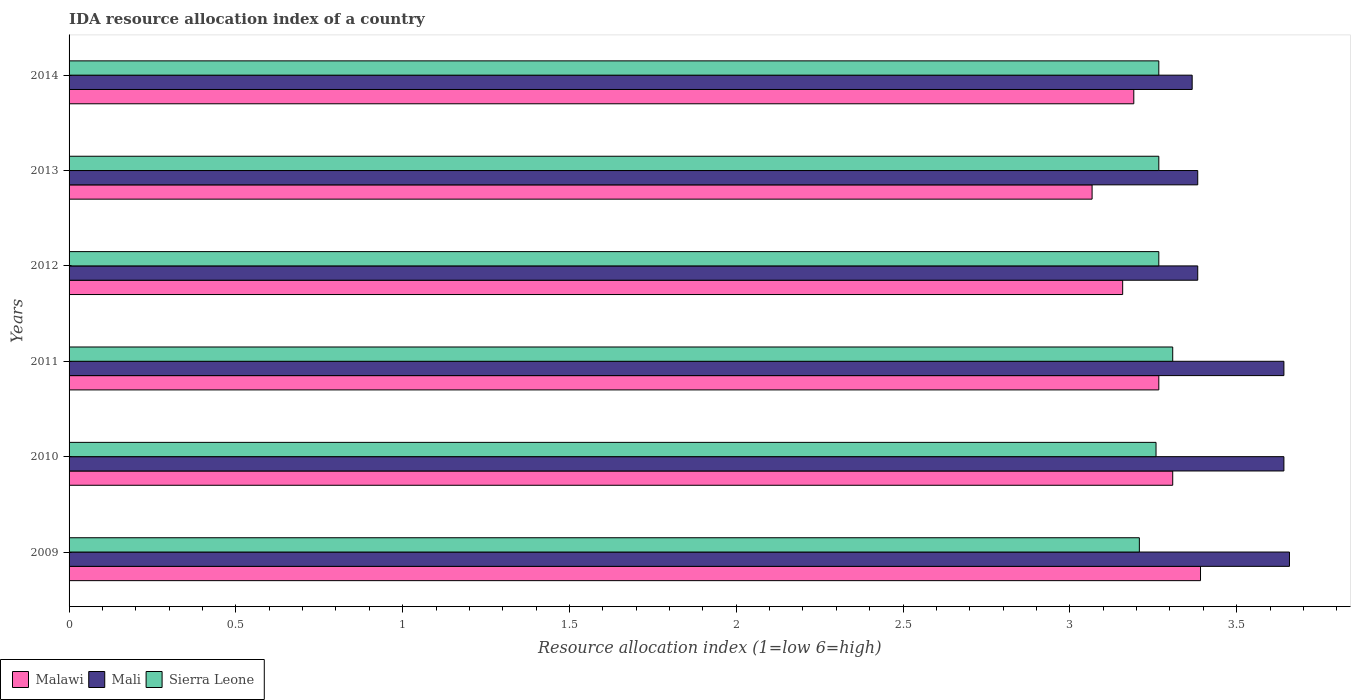How many groups of bars are there?
Provide a short and direct response. 6. Are the number of bars per tick equal to the number of legend labels?
Your response must be concise. Yes. How many bars are there on the 5th tick from the top?
Offer a very short reply. 3. What is the label of the 6th group of bars from the top?
Your response must be concise. 2009. In how many cases, is the number of bars for a given year not equal to the number of legend labels?
Offer a terse response. 0. What is the IDA resource allocation index in Sierra Leone in 2009?
Offer a very short reply. 3.21. Across all years, what is the maximum IDA resource allocation index in Mali?
Offer a terse response. 3.66. Across all years, what is the minimum IDA resource allocation index in Malawi?
Provide a succinct answer. 3.07. In which year was the IDA resource allocation index in Mali maximum?
Your response must be concise. 2009. In which year was the IDA resource allocation index in Sierra Leone minimum?
Your answer should be compact. 2009. What is the total IDA resource allocation index in Mali in the graph?
Ensure brevity in your answer.  21.07. What is the difference between the IDA resource allocation index in Mali in 2009 and that in 2010?
Provide a short and direct response. 0.02. What is the difference between the IDA resource allocation index in Sierra Leone in 2010 and the IDA resource allocation index in Mali in 2009?
Offer a terse response. -0.4. What is the average IDA resource allocation index in Malawi per year?
Give a very brief answer. 3.23. In the year 2010, what is the difference between the IDA resource allocation index in Malawi and IDA resource allocation index in Mali?
Make the answer very short. -0.33. What is the ratio of the IDA resource allocation index in Sierra Leone in 2009 to that in 2013?
Give a very brief answer. 0.98. What is the difference between the highest and the second highest IDA resource allocation index in Sierra Leone?
Make the answer very short. 0.04. What is the difference between the highest and the lowest IDA resource allocation index in Mali?
Keep it short and to the point. 0.29. Is the sum of the IDA resource allocation index in Sierra Leone in 2009 and 2010 greater than the maximum IDA resource allocation index in Malawi across all years?
Offer a very short reply. Yes. What does the 1st bar from the top in 2011 represents?
Provide a short and direct response. Sierra Leone. What does the 2nd bar from the bottom in 2014 represents?
Your answer should be very brief. Mali. Is it the case that in every year, the sum of the IDA resource allocation index in Malawi and IDA resource allocation index in Sierra Leone is greater than the IDA resource allocation index in Mali?
Your response must be concise. Yes. How many bars are there?
Keep it short and to the point. 18. How many years are there in the graph?
Keep it short and to the point. 6. What is the difference between two consecutive major ticks on the X-axis?
Provide a short and direct response. 0.5. Are the values on the major ticks of X-axis written in scientific E-notation?
Offer a terse response. No. Does the graph contain any zero values?
Make the answer very short. No. What is the title of the graph?
Give a very brief answer. IDA resource allocation index of a country. Does "Middle income" appear as one of the legend labels in the graph?
Your response must be concise. No. What is the label or title of the X-axis?
Offer a terse response. Resource allocation index (1=low 6=high). What is the label or title of the Y-axis?
Offer a terse response. Years. What is the Resource allocation index (1=low 6=high) in Malawi in 2009?
Give a very brief answer. 3.39. What is the Resource allocation index (1=low 6=high) of Mali in 2009?
Your answer should be very brief. 3.66. What is the Resource allocation index (1=low 6=high) of Sierra Leone in 2009?
Offer a very short reply. 3.21. What is the Resource allocation index (1=low 6=high) in Malawi in 2010?
Offer a terse response. 3.31. What is the Resource allocation index (1=low 6=high) in Mali in 2010?
Give a very brief answer. 3.64. What is the Resource allocation index (1=low 6=high) in Sierra Leone in 2010?
Your answer should be very brief. 3.26. What is the Resource allocation index (1=low 6=high) of Malawi in 2011?
Give a very brief answer. 3.27. What is the Resource allocation index (1=low 6=high) in Mali in 2011?
Give a very brief answer. 3.64. What is the Resource allocation index (1=low 6=high) in Sierra Leone in 2011?
Offer a very short reply. 3.31. What is the Resource allocation index (1=low 6=high) of Malawi in 2012?
Make the answer very short. 3.16. What is the Resource allocation index (1=low 6=high) of Mali in 2012?
Your answer should be compact. 3.38. What is the Resource allocation index (1=low 6=high) of Sierra Leone in 2012?
Your answer should be very brief. 3.27. What is the Resource allocation index (1=low 6=high) in Malawi in 2013?
Offer a very short reply. 3.07. What is the Resource allocation index (1=low 6=high) in Mali in 2013?
Your response must be concise. 3.38. What is the Resource allocation index (1=low 6=high) of Sierra Leone in 2013?
Make the answer very short. 3.27. What is the Resource allocation index (1=low 6=high) of Malawi in 2014?
Your response must be concise. 3.19. What is the Resource allocation index (1=low 6=high) in Mali in 2014?
Keep it short and to the point. 3.37. What is the Resource allocation index (1=low 6=high) in Sierra Leone in 2014?
Keep it short and to the point. 3.27. Across all years, what is the maximum Resource allocation index (1=low 6=high) in Malawi?
Provide a short and direct response. 3.39. Across all years, what is the maximum Resource allocation index (1=low 6=high) of Mali?
Offer a terse response. 3.66. Across all years, what is the maximum Resource allocation index (1=low 6=high) in Sierra Leone?
Your answer should be very brief. 3.31. Across all years, what is the minimum Resource allocation index (1=low 6=high) in Malawi?
Offer a very short reply. 3.07. Across all years, what is the minimum Resource allocation index (1=low 6=high) in Mali?
Offer a very short reply. 3.37. Across all years, what is the minimum Resource allocation index (1=low 6=high) of Sierra Leone?
Your answer should be very brief. 3.21. What is the total Resource allocation index (1=low 6=high) in Malawi in the graph?
Offer a terse response. 19.38. What is the total Resource allocation index (1=low 6=high) of Mali in the graph?
Your answer should be compact. 21.07. What is the total Resource allocation index (1=low 6=high) of Sierra Leone in the graph?
Ensure brevity in your answer.  19.57. What is the difference between the Resource allocation index (1=low 6=high) in Malawi in 2009 and that in 2010?
Provide a short and direct response. 0.08. What is the difference between the Resource allocation index (1=low 6=high) in Mali in 2009 and that in 2010?
Make the answer very short. 0.02. What is the difference between the Resource allocation index (1=low 6=high) in Sierra Leone in 2009 and that in 2010?
Offer a terse response. -0.05. What is the difference between the Resource allocation index (1=low 6=high) of Malawi in 2009 and that in 2011?
Provide a succinct answer. 0.12. What is the difference between the Resource allocation index (1=low 6=high) in Mali in 2009 and that in 2011?
Provide a succinct answer. 0.02. What is the difference between the Resource allocation index (1=low 6=high) in Malawi in 2009 and that in 2012?
Your answer should be compact. 0.23. What is the difference between the Resource allocation index (1=low 6=high) of Mali in 2009 and that in 2012?
Offer a very short reply. 0.28. What is the difference between the Resource allocation index (1=low 6=high) in Sierra Leone in 2009 and that in 2012?
Your answer should be compact. -0.06. What is the difference between the Resource allocation index (1=low 6=high) in Malawi in 2009 and that in 2013?
Offer a terse response. 0.33. What is the difference between the Resource allocation index (1=low 6=high) of Mali in 2009 and that in 2013?
Keep it short and to the point. 0.28. What is the difference between the Resource allocation index (1=low 6=high) in Sierra Leone in 2009 and that in 2013?
Provide a succinct answer. -0.06. What is the difference between the Resource allocation index (1=low 6=high) in Mali in 2009 and that in 2014?
Your answer should be very brief. 0.29. What is the difference between the Resource allocation index (1=low 6=high) in Sierra Leone in 2009 and that in 2014?
Your answer should be very brief. -0.06. What is the difference between the Resource allocation index (1=low 6=high) in Malawi in 2010 and that in 2011?
Your answer should be compact. 0.04. What is the difference between the Resource allocation index (1=low 6=high) in Mali in 2010 and that in 2012?
Ensure brevity in your answer.  0.26. What is the difference between the Resource allocation index (1=low 6=high) in Sierra Leone in 2010 and that in 2012?
Provide a short and direct response. -0.01. What is the difference between the Resource allocation index (1=low 6=high) of Malawi in 2010 and that in 2013?
Offer a terse response. 0.24. What is the difference between the Resource allocation index (1=low 6=high) in Mali in 2010 and that in 2013?
Ensure brevity in your answer.  0.26. What is the difference between the Resource allocation index (1=low 6=high) in Sierra Leone in 2010 and that in 2013?
Your response must be concise. -0.01. What is the difference between the Resource allocation index (1=low 6=high) of Malawi in 2010 and that in 2014?
Keep it short and to the point. 0.12. What is the difference between the Resource allocation index (1=low 6=high) of Mali in 2010 and that in 2014?
Provide a succinct answer. 0.28. What is the difference between the Resource allocation index (1=low 6=high) of Sierra Leone in 2010 and that in 2014?
Your answer should be very brief. -0.01. What is the difference between the Resource allocation index (1=low 6=high) in Malawi in 2011 and that in 2012?
Offer a very short reply. 0.11. What is the difference between the Resource allocation index (1=low 6=high) in Mali in 2011 and that in 2012?
Offer a terse response. 0.26. What is the difference between the Resource allocation index (1=low 6=high) of Sierra Leone in 2011 and that in 2012?
Make the answer very short. 0.04. What is the difference between the Resource allocation index (1=low 6=high) in Mali in 2011 and that in 2013?
Your answer should be very brief. 0.26. What is the difference between the Resource allocation index (1=low 6=high) of Sierra Leone in 2011 and that in 2013?
Ensure brevity in your answer.  0.04. What is the difference between the Resource allocation index (1=low 6=high) in Malawi in 2011 and that in 2014?
Your answer should be compact. 0.07. What is the difference between the Resource allocation index (1=low 6=high) of Mali in 2011 and that in 2014?
Provide a short and direct response. 0.28. What is the difference between the Resource allocation index (1=low 6=high) in Sierra Leone in 2011 and that in 2014?
Your answer should be very brief. 0.04. What is the difference between the Resource allocation index (1=low 6=high) of Malawi in 2012 and that in 2013?
Make the answer very short. 0.09. What is the difference between the Resource allocation index (1=low 6=high) of Malawi in 2012 and that in 2014?
Your answer should be compact. -0.03. What is the difference between the Resource allocation index (1=low 6=high) in Mali in 2012 and that in 2014?
Your response must be concise. 0.02. What is the difference between the Resource allocation index (1=low 6=high) in Sierra Leone in 2012 and that in 2014?
Make the answer very short. -0. What is the difference between the Resource allocation index (1=low 6=high) in Malawi in 2013 and that in 2014?
Your response must be concise. -0.12. What is the difference between the Resource allocation index (1=low 6=high) in Mali in 2013 and that in 2014?
Keep it short and to the point. 0.02. What is the difference between the Resource allocation index (1=low 6=high) of Sierra Leone in 2013 and that in 2014?
Keep it short and to the point. -0. What is the difference between the Resource allocation index (1=low 6=high) in Malawi in 2009 and the Resource allocation index (1=low 6=high) in Sierra Leone in 2010?
Provide a short and direct response. 0.13. What is the difference between the Resource allocation index (1=low 6=high) of Mali in 2009 and the Resource allocation index (1=low 6=high) of Sierra Leone in 2010?
Your answer should be very brief. 0.4. What is the difference between the Resource allocation index (1=low 6=high) in Malawi in 2009 and the Resource allocation index (1=low 6=high) in Sierra Leone in 2011?
Your answer should be compact. 0.08. What is the difference between the Resource allocation index (1=low 6=high) in Mali in 2009 and the Resource allocation index (1=low 6=high) in Sierra Leone in 2011?
Offer a very short reply. 0.35. What is the difference between the Resource allocation index (1=low 6=high) of Malawi in 2009 and the Resource allocation index (1=low 6=high) of Mali in 2012?
Ensure brevity in your answer.  0.01. What is the difference between the Resource allocation index (1=low 6=high) in Malawi in 2009 and the Resource allocation index (1=low 6=high) in Sierra Leone in 2012?
Make the answer very short. 0.12. What is the difference between the Resource allocation index (1=low 6=high) of Mali in 2009 and the Resource allocation index (1=low 6=high) of Sierra Leone in 2012?
Provide a short and direct response. 0.39. What is the difference between the Resource allocation index (1=low 6=high) in Malawi in 2009 and the Resource allocation index (1=low 6=high) in Mali in 2013?
Make the answer very short. 0.01. What is the difference between the Resource allocation index (1=low 6=high) of Mali in 2009 and the Resource allocation index (1=low 6=high) of Sierra Leone in 2013?
Your response must be concise. 0.39. What is the difference between the Resource allocation index (1=low 6=high) of Malawi in 2009 and the Resource allocation index (1=low 6=high) of Mali in 2014?
Give a very brief answer. 0.03. What is the difference between the Resource allocation index (1=low 6=high) in Malawi in 2009 and the Resource allocation index (1=low 6=high) in Sierra Leone in 2014?
Ensure brevity in your answer.  0.12. What is the difference between the Resource allocation index (1=low 6=high) of Mali in 2009 and the Resource allocation index (1=low 6=high) of Sierra Leone in 2014?
Ensure brevity in your answer.  0.39. What is the difference between the Resource allocation index (1=low 6=high) in Malawi in 2010 and the Resource allocation index (1=low 6=high) in Sierra Leone in 2011?
Provide a short and direct response. 0. What is the difference between the Resource allocation index (1=low 6=high) in Malawi in 2010 and the Resource allocation index (1=low 6=high) in Mali in 2012?
Provide a short and direct response. -0.07. What is the difference between the Resource allocation index (1=low 6=high) of Malawi in 2010 and the Resource allocation index (1=low 6=high) of Sierra Leone in 2012?
Offer a terse response. 0.04. What is the difference between the Resource allocation index (1=low 6=high) in Malawi in 2010 and the Resource allocation index (1=low 6=high) in Mali in 2013?
Your answer should be very brief. -0.07. What is the difference between the Resource allocation index (1=low 6=high) in Malawi in 2010 and the Resource allocation index (1=low 6=high) in Sierra Leone in 2013?
Make the answer very short. 0.04. What is the difference between the Resource allocation index (1=low 6=high) of Malawi in 2010 and the Resource allocation index (1=low 6=high) of Mali in 2014?
Your answer should be compact. -0.06. What is the difference between the Resource allocation index (1=low 6=high) of Malawi in 2010 and the Resource allocation index (1=low 6=high) of Sierra Leone in 2014?
Your answer should be very brief. 0.04. What is the difference between the Resource allocation index (1=low 6=high) in Malawi in 2011 and the Resource allocation index (1=low 6=high) in Mali in 2012?
Your answer should be compact. -0.12. What is the difference between the Resource allocation index (1=low 6=high) of Malawi in 2011 and the Resource allocation index (1=low 6=high) of Mali in 2013?
Provide a short and direct response. -0.12. What is the difference between the Resource allocation index (1=low 6=high) in Malawi in 2012 and the Resource allocation index (1=low 6=high) in Mali in 2013?
Your response must be concise. -0.23. What is the difference between the Resource allocation index (1=low 6=high) in Malawi in 2012 and the Resource allocation index (1=low 6=high) in Sierra Leone in 2013?
Give a very brief answer. -0.11. What is the difference between the Resource allocation index (1=low 6=high) in Mali in 2012 and the Resource allocation index (1=low 6=high) in Sierra Leone in 2013?
Your response must be concise. 0.12. What is the difference between the Resource allocation index (1=low 6=high) in Malawi in 2012 and the Resource allocation index (1=low 6=high) in Mali in 2014?
Your answer should be very brief. -0.21. What is the difference between the Resource allocation index (1=low 6=high) in Malawi in 2012 and the Resource allocation index (1=low 6=high) in Sierra Leone in 2014?
Keep it short and to the point. -0.11. What is the difference between the Resource allocation index (1=low 6=high) of Mali in 2012 and the Resource allocation index (1=low 6=high) of Sierra Leone in 2014?
Offer a very short reply. 0.12. What is the difference between the Resource allocation index (1=low 6=high) of Malawi in 2013 and the Resource allocation index (1=low 6=high) of Sierra Leone in 2014?
Offer a very short reply. -0.2. What is the difference between the Resource allocation index (1=low 6=high) of Mali in 2013 and the Resource allocation index (1=low 6=high) of Sierra Leone in 2014?
Keep it short and to the point. 0.12. What is the average Resource allocation index (1=low 6=high) of Malawi per year?
Your answer should be compact. 3.23. What is the average Resource allocation index (1=low 6=high) in Mali per year?
Give a very brief answer. 3.51. What is the average Resource allocation index (1=low 6=high) of Sierra Leone per year?
Ensure brevity in your answer.  3.26. In the year 2009, what is the difference between the Resource allocation index (1=low 6=high) of Malawi and Resource allocation index (1=low 6=high) of Mali?
Your response must be concise. -0.27. In the year 2009, what is the difference between the Resource allocation index (1=low 6=high) of Malawi and Resource allocation index (1=low 6=high) of Sierra Leone?
Make the answer very short. 0.18. In the year 2009, what is the difference between the Resource allocation index (1=low 6=high) of Mali and Resource allocation index (1=low 6=high) of Sierra Leone?
Make the answer very short. 0.45. In the year 2010, what is the difference between the Resource allocation index (1=low 6=high) of Malawi and Resource allocation index (1=low 6=high) of Sierra Leone?
Your response must be concise. 0.05. In the year 2010, what is the difference between the Resource allocation index (1=low 6=high) of Mali and Resource allocation index (1=low 6=high) of Sierra Leone?
Keep it short and to the point. 0.38. In the year 2011, what is the difference between the Resource allocation index (1=low 6=high) in Malawi and Resource allocation index (1=low 6=high) in Mali?
Give a very brief answer. -0.38. In the year 2011, what is the difference between the Resource allocation index (1=low 6=high) of Malawi and Resource allocation index (1=low 6=high) of Sierra Leone?
Offer a terse response. -0.04. In the year 2011, what is the difference between the Resource allocation index (1=low 6=high) in Mali and Resource allocation index (1=low 6=high) in Sierra Leone?
Your answer should be very brief. 0.33. In the year 2012, what is the difference between the Resource allocation index (1=low 6=high) of Malawi and Resource allocation index (1=low 6=high) of Mali?
Your answer should be compact. -0.23. In the year 2012, what is the difference between the Resource allocation index (1=low 6=high) in Malawi and Resource allocation index (1=low 6=high) in Sierra Leone?
Your answer should be compact. -0.11. In the year 2012, what is the difference between the Resource allocation index (1=low 6=high) of Mali and Resource allocation index (1=low 6=high) of Sierra Leone?
Your answer should be very brief. 0.12. In the year 2013, what is the difference between the Resource allocation index (1=low 6=high) of Malawi and Resource allocation index (1=low 6=high) of Mali?
Keep it short and to the point. -0.32. In the year 2013, what is the difference between the Resource allocation index (1=low 6=high) of Mali and Resource allocation index (1=low 6=high) of Sierra Leone?
Keep it short and to the point. 0.12. In the year 2014, what is the difference between the Resource allocation index (1=low 6=high) in Malawi and Resource allocation index (1=low 6=high) in Mali?
Provide a succinct answer. -0.17. In the year 2014, what is the difference between the Resource allocation index (1=low 6=high) in Malawi and Resource allocation index (1=low 6=high) in Sierra Leone?
Offer a terse response. -0.07. What is the ratio of the Resource allocation index (1=low 6=high) of Malawi in 2009 to that in 2010?
Provide a short and direct response. 1.03. What is the ratio of the Resource allocation index (1=low 6=high) of Sierra Leone in 2009 to that in 2010?
Make the answer very short. 0.98. What is the ratio of the Resource allocation index (1=low 6=high) of Malawi in 2009 to that in 2011?
Your answer should be very brief. 1.04. What is the ratio of the Resource allocation index (1=low 6=high) in Mali in 2009 to that in 2011?
Provide a succinct answer. 1. What is the ratio of the Resource allocation index (1=low 6=high) of Sierra Leone in 2009 to that in 2011?
Ensure brevity in your answer.  0.97. What is the ratio of the Resource allocation index (1=low 6=high) of Malawi in 2009 to that in 2012?
Your answer should be compact. 1.07. What is the ratio of the Resource allocation index (1=low 6=high) in Mali in 2009 to that in 2012?
Offer a very short reply. 1.08. What is the ratio of the Resource allocation index (1=low 6=high) of Sierra Leone in 2009 to that in 2012?
Give a very brief answer. 0.98. What is the ratio of the Resource allocation index (1=low 6=high) in Malawi in 2009 to that in 2013?
Your answer should be very brief. 1.11. What is the ratio of the Resource allocation index (1=low 6=high) of Mali in 2009 to that in 2013?
Your response must be concise. 1.08. What is the ratio of the Resource allocation index (1=low 6=high) in Sierra Leone in 2009 to that in 2013?
Ensure brevity in your answer.  0.98. What is the ratio of the Resource allocation index (1=low 6=high) in Malawi in 2009 to that in 2014?
Keep it short and to the point. 1.06. What is the ratio of the Resource allocation index (1=low 6=high) in Mali in 2009 to that in 2014?
Offer a very short reply. 1.09. What is the ratio of the Resource allocation index (1=low 6=high) in Sierra Leone in 2009 to that in 2014?
Offer a very short reply. 0.98. What is the ratio of the Resource allocation index (1=low 6=high) of Malawi in 2010 to that in 2011?
Keep it short and to the point. 1.01. What is the ratio of the Resource allocation index (1=low 6=high) of Mali in 2010 to that in 2011?
Keep it short and to the point. 1. What is the ratio of the Resource allocation index (1=low 6=high) in Sierra Leone in 2010 to that in 2011?
Offer a terse response. 0.98. What is the ratio of the Resource allocation index (1=low 6=high) of Malawi in 2010 to that in 2012?
Your answer should be compact. 1.05. What is the ratio of the Resource allocation index (1=low 6=high) of Mali in 2010 to that in 2012?
Provide a short and direct response. 1.08. What is the ratio of the Resource allocation index (1=low 6=high) in Sierra Leone in 2010 to that in 2012?
Provide a short and direct response. 1. What is the ratio of the Resource allocation index (1=low 6=high) in Malawi in 2010 to that in 2013?
Offer a very short reply. 1.08. What is the ratio of the Resource allocation index (1=low 6=high) of Mali in 2010 to that in 2013?
Make the answer very short. 1.08. What is the ratio of the Resource allocation index (1=low 6=high) of Malawi in 2010 to that in 2014?
Your answer should be compact. 1.04. What is the ratio of the Resource allocation index (1=low 6=high) of Mali in 2010 to that in 2014?
Make the answer very short. 1.08. What is the ratio of the Resource allocation index (1=low 6=high) of Malawi in 2011 to that in 2012?
Provide a short and direct response. 1.03. What is the ratio of the Resource allocation index (1=low 6=high) of Mali in 2011 to that in 2012?
Offer a terse response. 1.08. What is the ratio of the Resource allocation index (1=low 6=high) in Sierra Leone in 2011 to that in 2012?
Provide a succinct answer. 1.01. What is the ratio of the Resource allocation index (1=low 6=high) of Malawi in 2011 to that in 2013?
Ensure brevity in your answer.  1.07. What is the ratio of the Resource allocation index (1=low 6=high) of Mali in 2011 to that in 2013?
Provide a succinct answer. 1.08. What is the ratio of the Resource allocation index (1=low 6=high) of Sierra Leone in 2011 to that in 2013?
Provide a succinct answer. 1.01. What is the ratio of the Resource allocation index (1=low 6=high) in Malawi in 2011 to that in 2014?
Provide a succinct answer. 1.02. What is the ratio of the Resource allocation index (1=low 6=high) of Mali in 2011 to that in 2014?
Give a very brief answer. 1.08. What is the ratio of the Resource allocation index (1=low 6=high) in Sierra Leone in 2011 to that in 2014?
Offer a terse response. 1.01. What is the ratio of the Resource allocation index (1=low 6=high) in Malawi in 2012 to that in 2013?
Offer a terse response. 1.03. What is the ratio of the Resource allocation index (1=low 6=high) in Sierra Leone in 2012 to that in 2013?
Make the answer very short. 1. What is the ratio of the Resource allocation index (1=low 6=high) of Malawi in 2012 to that in 2014?
Your answer should be very brief. 0.99. What is the ratio of the Resource allocation index (1=low 6=high) in Mali in 2012 to that in 2014?
Your answer should be very brief. 1. What is the ratio of the Resource allocation index (1=low 6=high) in Sierra Leone in 2012 to that in 2014?
Your answer should be very brief. 1. What is the ratio of the Resource allocation index (1=low 6=high) of Malawi in 2013 to that in 2014?
Offer a very short reply. 0.96. What is the difference between the highest and the second highest Resource allocation index (1=low 6=high) in Malawi?
Your response must be concise. 0.08. What is the difference between the highest and the second highest Resource allocation index (1=low 6=high) of Mali?
Give a very brief answer. 0.02. What is the difference between the highest and the second highest Resource allocation index (1=low 6=high) of Sierra Leone?
Your answer should be very brief. 0.04. What is the difference between the highest and the lowest Resource allocation index (1=low 6=high) in Malawi?
Offer a very short reply. 0.33. What is the difference between the highest and the lowest Resource allocation index (1=low 6=high) in Mali?
Make the answer very short. 0.29. What is the difference between the highest and the lowest Resource allocation index (1=low 6=high) of Sierra Leone?
Make the answer very short. 0.1. 